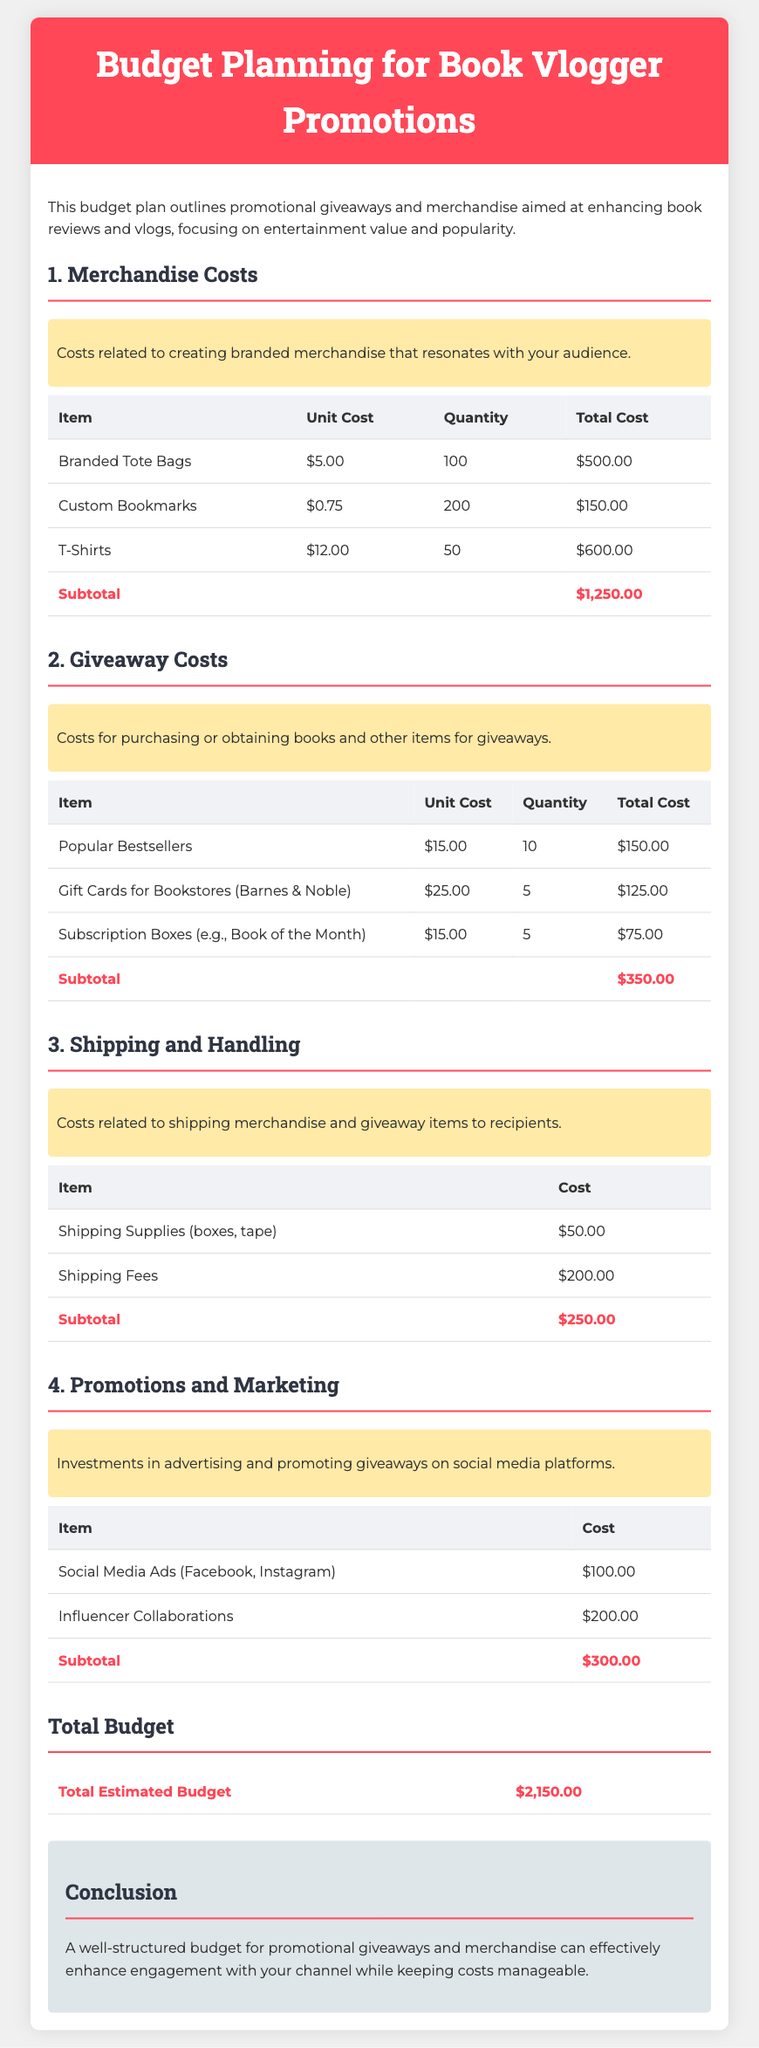What is the total estimated budget? The total estimated budget is summarized at the end of the document, which is $2,150.00.
Answer: $2,150.00 How many branded tote bags are included? The document lists that 100 branded tote bags are included under merchandise costs.
Answer: 100 What is the unit cost of custom bookmarks? The document states that the unit cost for custom bookmarks is $0.75.
Answer: $0.75 How much is allocated for social media ads? The budget plan shows that $100.00 is allocated for social media ads under promotions and marketing.
Answer: $100.00 What is the subtotal for shipping fees? The subtotal for shipping fees is indicated clearly in the shipping and handling section, totaling $200.00.
Answer: $200.00 What type of items are included in giveaway costs? The document mentions popular bestsellers, gift cards, and subscription boxes as items for giveaways.
Answer: popular bestsellers, gift cards, subscription boxes What is the total cost for custom bookmarks? The total cost for custom bookmarks is calculated as $150.00 in the merchandise costs section.
Answer: $150.00 How much are influencer collaborations? The budget allocates $200.00 for influencer collaborations under promotions and marketing.
Answer: $200.00 What is the total cost for merchandise? The subtotal for merchandise costs is detailed as $1,250.00 in the document.
Answer: $1,250.00 